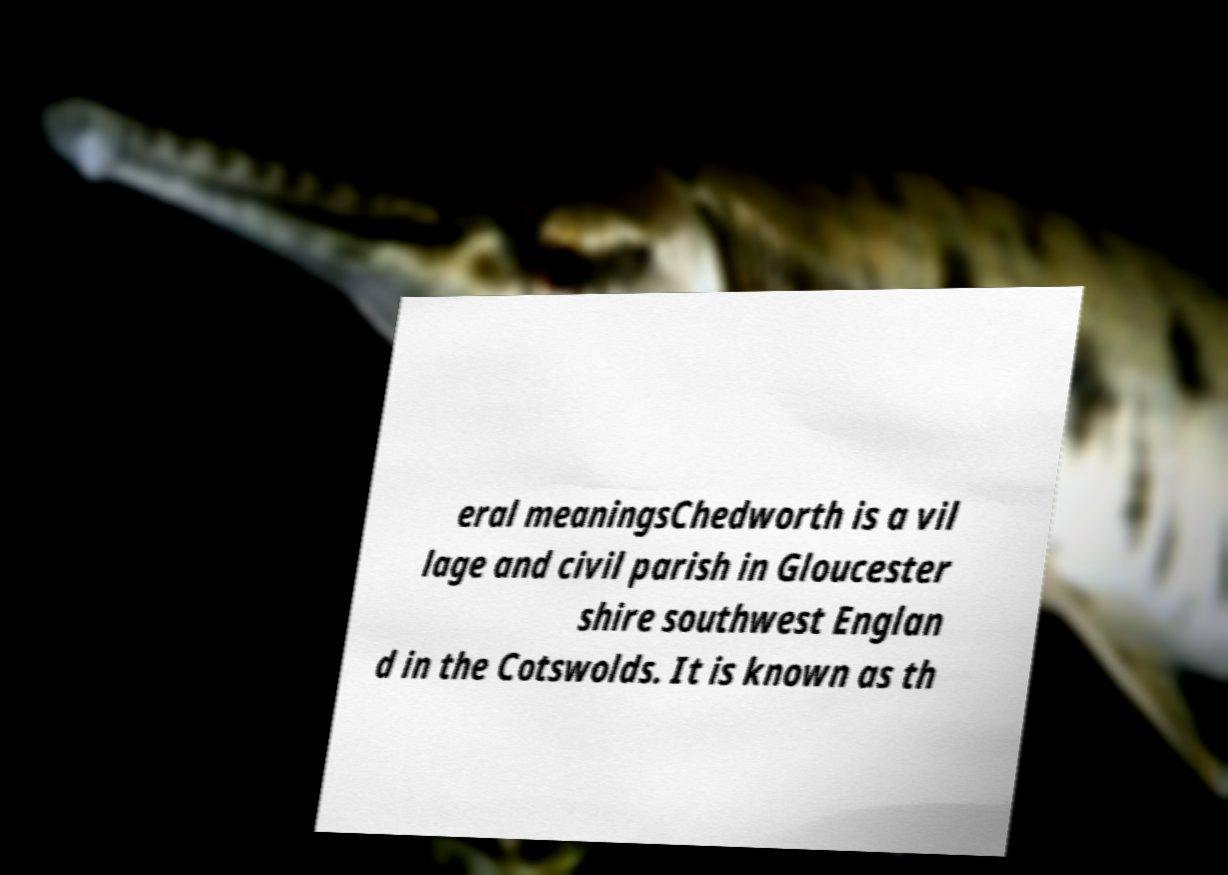I need the written content from this picture converted into text. Can you do that? eral meaningsChedworth is a vil lage and civil parish in Gloucester shire southwest Englan d in the Cotswolds. It is known as th 